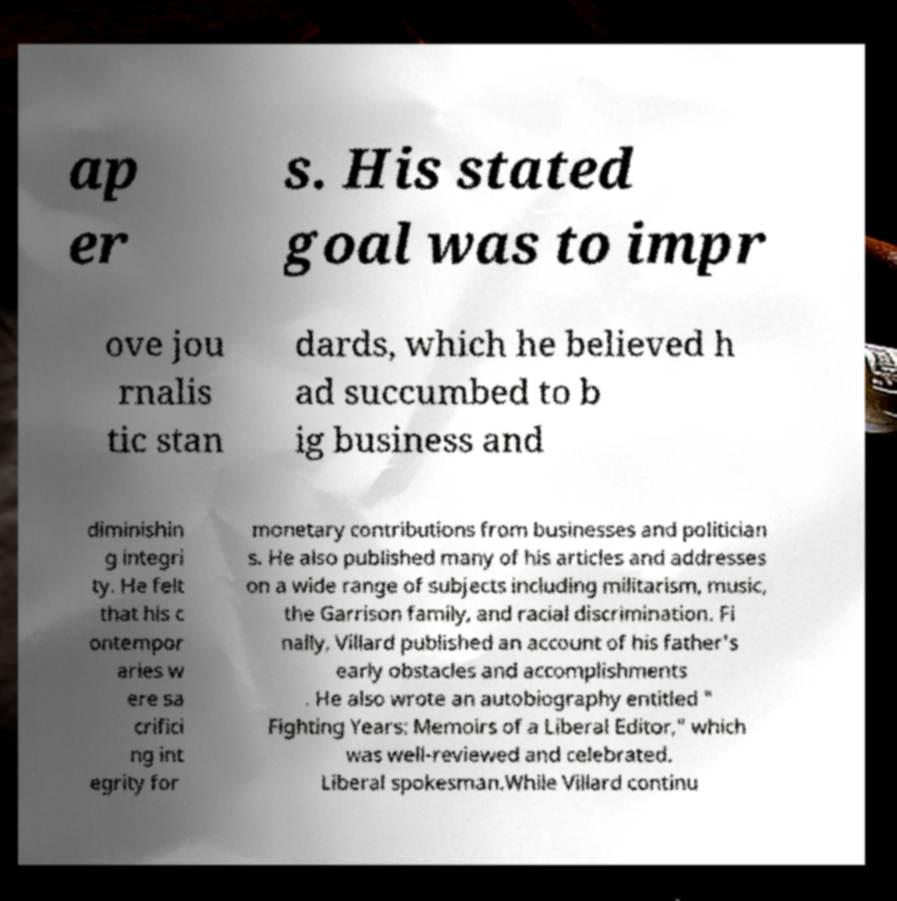Please read and relay the text visible in this image. What does it say? ap er s. His stated goal was to impr ove jou rnalis tic stan dards, which he believed h ad succumbed to b ig business and diminishin g integri ty. He felt that his c ontempor aries w ere sa crifici ng int egrity for monetary contributions from businesses and politician s. He also published many of his articles and addresses on a wide range of subjects including militarism, music, the Garrison family, and racial discrimination. Fi nally, Villard published an account of his father's early obstacles and accomplishments . He also wrote an autobiography entitled " Fighting Years: Memoirs of a Liberal Editor," which was well-reviewed and celebrated. Liberal spokesman.While Villard continu 